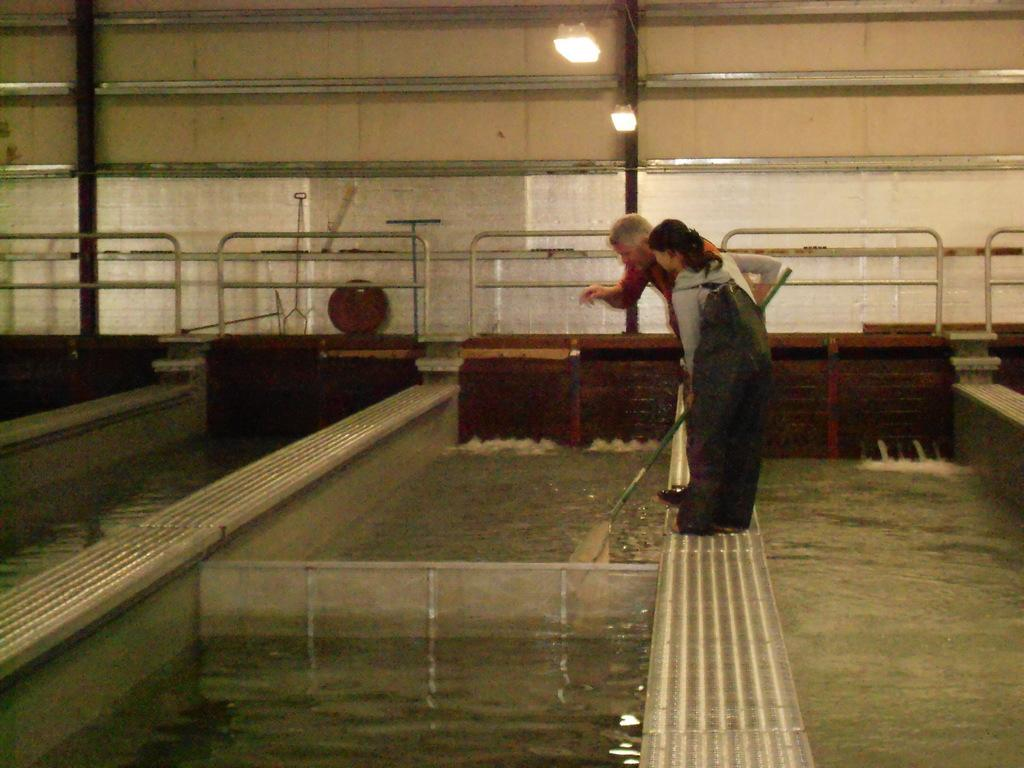What is the main object in the image? There is a water tank in the image. What can be seen at the top of the image? There are lights at the top of the image. How many people are in the image? There are two persons standing in the middle of the image. What are the two persons wearing? The two persons are wearing clothes. What type of zinc is present in the image? There is no zinc present in the image. How much dirt can be seen on the clothes of the two persons? The provided facts do not mention any dirt on the clothes of the two persons. 